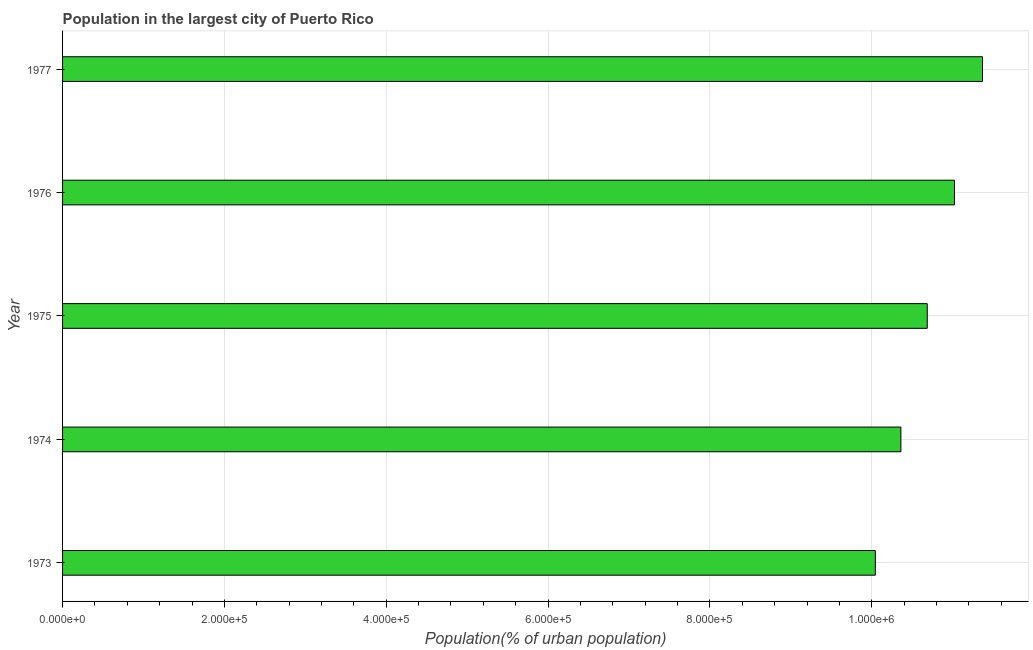Does the graph contain grids?
Give a very brief answer. Yes. What is the title of the graph?
Your answer should be compact. Population in the largest city of Puerto Rico. What is the label or title of the X-axis?
Your answer should be very brief. Population(% of urban population). What is the label or title of the Y-axis?
Provide a succinct answer. Year. What is the population in largest city in 1973?
Your answer should be compact. 1.00e+06. Across all years, what is the maximum population in largest city?
Keep it short and to the point. 1.14e+06. Across all years, what is the minimum population in largest city?
Give a very brief answer. 1.00e+06. In which year was the population in largest city maximum?
Your answer should be compact. 1977. In which year was the population in largest city minimum?
Your answer should be compact. 1973. What is the sum of the population in largest city?
Offer a terse response. 5.35e+06. What is the difference between the population in largest city in 1974 and 1976?
Provide a short and direct response. -6.62e+04. What is the average population in largest city per year?
Give a very brief answer. 1.07e+06. What is the median population in largest city?
Make the answer very short. 1.07e+06. Do a majority of the years between 1975 and 1973 (inclusive) have population in largest city greater than 400000 %?
Make the answer very short. Yes. Is the population in largest city in 1974 less than that in 1976?
Your response must be concise. Yes. What is the difference between the highest and the second highest population in largest city?
Your answer should be very brief. 3.46e+04. What is the difference between the highest and the lowest population in largest city?
Provide a short and direct response. 1.32e+05. How many bars are there?
Your answer should be very brief. 5. Are all the bars in the graph horizontal?
Make the answer very short. Yes. Are the values on the major ticks of X-axis written in scientific E-notation?
Make the answer very short. Yes. What is the Population(% of urban population) of 1973?
Your answer should be very brief. 1.00e+06. What is the Population(% of urban population) in 1974?
Keep it short and to the point. 1.04e+06. What is the Population(% of urban population) of 1975?
Your answer should be very brief. 1.07e+06. What is the Population(% of urban population) of 1976?
Give a very brief answer. 1.10e+06. What is the Population(% of urban population) in 1977?
Your answer should be very brief. 1.14e+06. What is the difference between the Population(% of urban population) in 1973 and 1974?
Offer a terse response. -3.16e+04. What is the difference between the Population(% of urban population) in 1973 and 1975?
Provide a succinct answer. -6.42e+04. What is the difference between the Population(% of urban population) in 1973 and 1976?
Make the answer very short. -9.78e+04. What is the difference between the Population(% of urban population) in 1973 and 1977?
Keep it short and to the point. -1.32e+05. What is the difference between the Population(% of urban population) in 1974 and 1975?
Your answer should be very brief. -3.26e+04. What is the difference between the Population(% of urban population) in 1974 and 1976?
Ensure brevity in your answer.  -6.62e+04. What is the difference between the Population(% of urban population) in 1974 and 1977?
Provide a short and direct response. -1.01e+05. What is the difference between the Population(% of urban population) in 1975 and 1976?
Your response must be concise. -3.37e+04. What is the difference between the Population(% of urban population) in 1975 and 1977?
Keep it short and to the point. -6.83e+04. What is the difference between the Population(% of urban population) in 1976 and 1977?
Offer a very short reply. -3.46e+04. What is the ratio of the Population(% of urban population) in 1973 to that in 1975?
Your answer should be very brief. 0.94. What is the ratio of the Population(% of urban population) in 1973 to that in 1976?
Offer a very short reply. 0.91. What is the ratio of the Population(% of urban population) in 1973 to that in 1977?
Give a very brief answer. 0.88. What is the ratio of the Population(% of urban population) in 1974 to that in 1975?
Provide a short and direct response. 0.97. What is the ratio of the Population(% of urban population) in 1974 to that in 1976?
Keep it short and to the point. 0.94. What is the ratio of the Population(% of urban population) in 1974 to that in 1977?
Your response must be concise. 0.91. What is the ratio of the Population(% of urban population) in 1975 to that in 1976?
Provide a short and direct response. 0.97. 